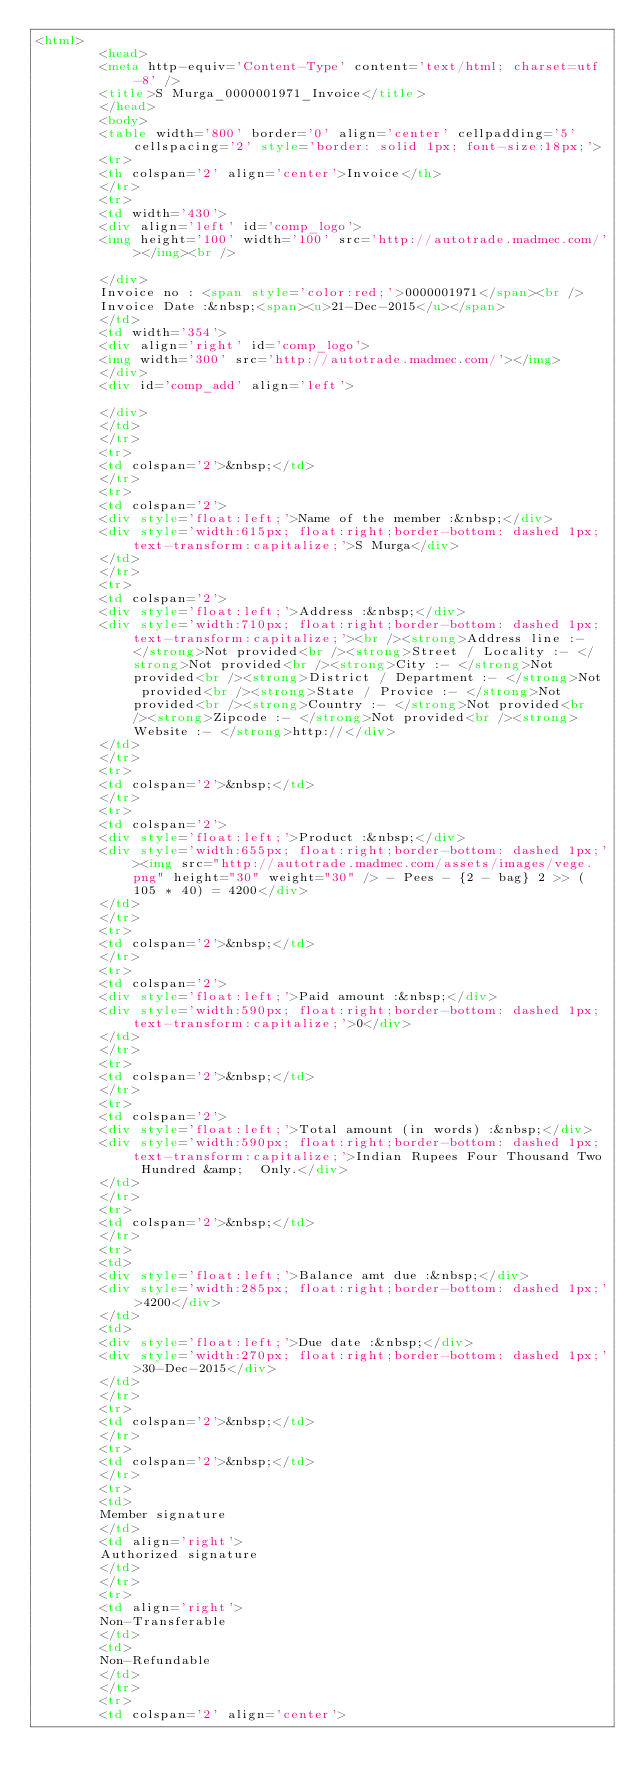Convert code to text. <code><loc_0><loc_0><loc_500><loc_500><_HTML_><html>
		<head>
		<meta http-equiv='Content-Type' content='text/html; charset=utf-8' />
		<title>S Murga_0000001971_Invoice</title>
		</head>
		<body>
		<table width='800' border='0' align='center' cellpadding='5' cellspacing='2' style='border: solid 1px; font-size:18px;'>
		<tr>
		<th colspan='2' align='center'>Invoice</th>
		</tr>
		<tr>
		<td width='430'>
		<div align='left' id='comp_logo'>
		<img height='100' width='100' src='http://autotrade.madmec.com/'></img><br />

		</div>
		Invoice no : <span style='color:red;'>0000001971</span><br />
		Invoice Date :&nbsp;<span><u>21-Dec-2015</u></span>
		</td>
		<td width='354'>
		<div align='right' id='comp_logo'>
		<img width='300' src='http://autotrade.madmec.com/'></img>
		</div>
		<div id='comp_add' align='left'>
		
		</div>
		</td>
		</tr>
		<tr>
		<td colspan='2'>&nbsp;</td>
		</tr>
		<tr>
		<td colspan='2'>
		<div style='float:left;'>Name of the member :&nbsp;</div>
		<div style='width:615px; float:right;border-bottom: dashed 1px; text-transform:capitalize;'>S Murga</div>
		</td>
		</tr>
		<tr>
		<td colspan='2'>
		<div style='float:left;'>Address :&nbsp;</div>
		<div style='width:710px; float:right;border-bottom: dashed 1px; text-transform:capitalize;'><br /><strong>Address line :- </strong>Not provided<br /><strong>Street / Locality :- </strong>Not provided<br /><strong>City :- </strong>Not provided<br /><strong>District / Department :- </strong>Not provided<br /><strong>State / Provice :- </strong>Not provided<br /><strong>Country :- </strong>Not provided<br /><strong>Zipcode :- </strong>Not provided<br /><strong>Website :- </strong>http://</div>
		</td>
		</tr>
		<tr>
		<td colspan='2'>&nbsp;</td>
		</tr>
		<tr>
		<td colspan='2'>
		<div style='float:left;'>Product :&nbsp;</div>
		<div style='width:655px; float:right;border-bottom: dashed 1px;'><img src="http://autotrade.madmec.com/assets/images/vege.png" height="30" weight="30" /> - Pees - {2 - bag} 2 >> (  105 * 40) = 4200</div>
		</td>
		</tr>
		<tr>
		<td colspan='2'>&nbsp;</td>
		</tr>
		<tr>
		<td colspan='2'>
		<div style='float:left;'>Paid amount :&nbsp;</div>
		<div style='width:590px; float:right;border-bottom: dashed 1px; text-transform:capitalize;'>0</div>
		</td>
		</tr>
		<tr>
		<td colspan='2'>&nbsp;</td>
		</tr>
		<tr>
		<td colspan='2'>
		<div style='float:left;'>Total amount (in words) :&nbsp;</div>
		<div style='width:590px; float:right;border-bottom: dashed 1px; text-transform:capitalize;'>Indian Rupees Four Thousand Two Hundred &amp;  Only.</div>
		</td>
		</tr>
		<tr>
		<td colspan='2'>&nbsp;</td>
		</tr>
		<tr>
		<td>
		<div style='float:left;'>Balance amt due :&nbsp;</div>
		<div style='width:285px; float:right;border-bottom: dashed 1px;'>4200</div>
		</td>
		<td>
		<div style='float:left;'>Due date :&nbsp;</div>
		<div style='width:270px; float:right;border-bottom: dashed 1px;'>30-Dec-2015</div>
		</td>
		</tr>
		<tr>
		<td colspan='2'>&nbsp;</td>
		</tr>
		<tr>
		<td colspan='2'>&nbsp;</td>
		</tr>
		<tr>
		<td>
		Member signature
		</td>
		<td align='right'>
		Authorized signature
		</td>
		</tr>
		<tr>
		<td align='right'>
		Non-Transferable
		</td>
		<td>
		Non-Refundable
		</td>
		</tr>
		<tr>
		<td colspan='2' align='center'></code> 